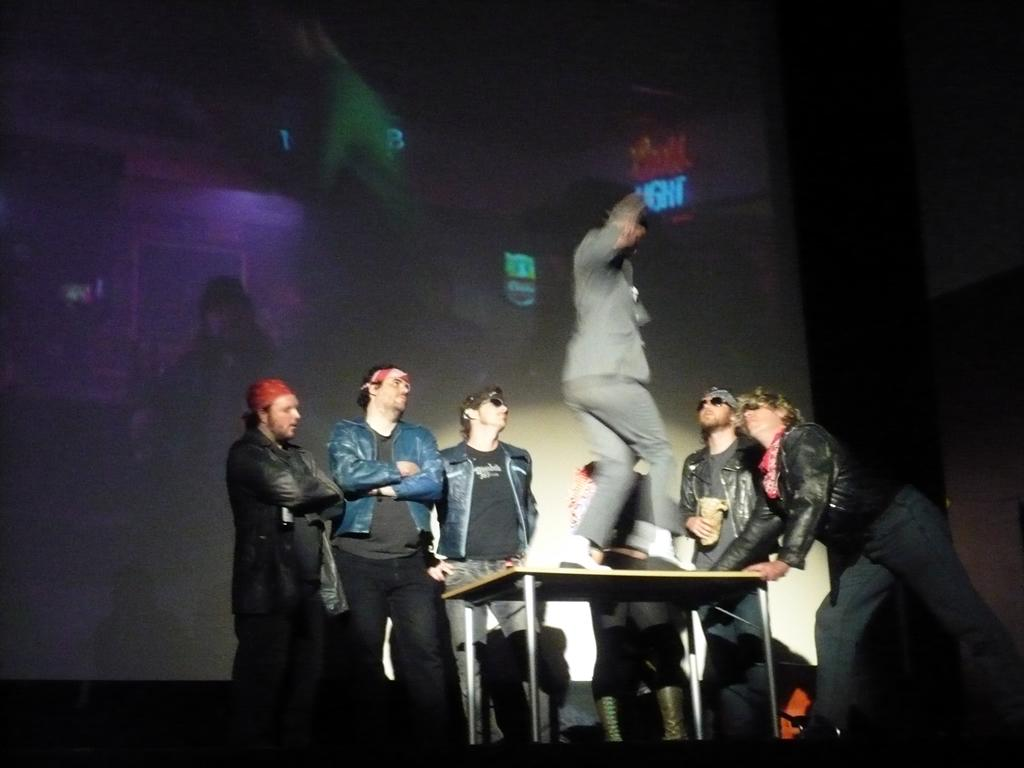What is the person in the image doing? The person is standing on a table in the image. Are there any other people present in the image? Yes, there are other people around the table in the image. What type of vase is being used to increase the selection of flowers in the image? There is no vase or flowers present in the image; it only features a person standing on a table and other people around the table. 